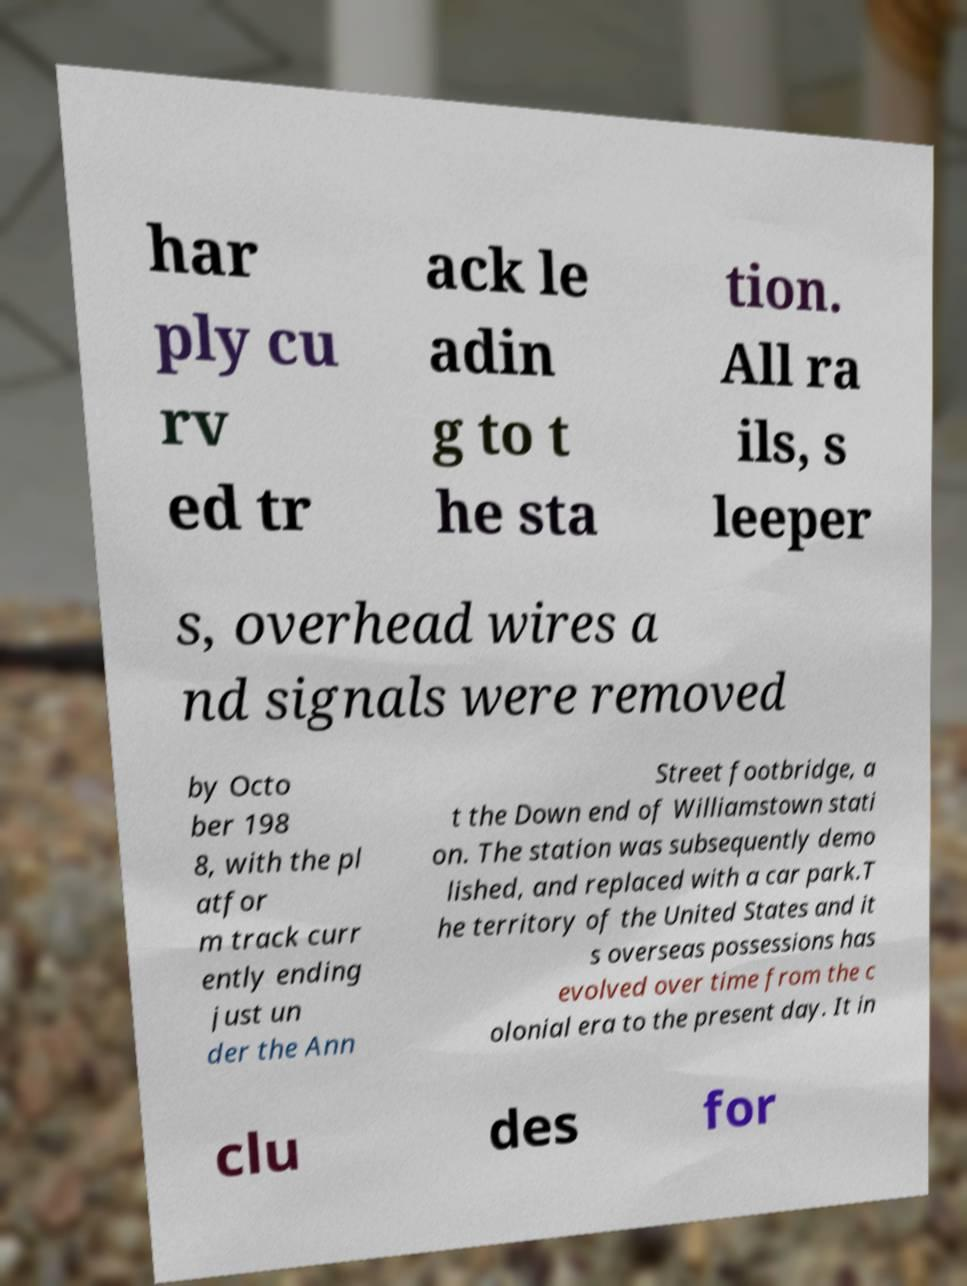Please identify and transcribe the text found in this image. har ply cu rv ed tr ack le adin g to t he sta tion. All ra ils, s leeper s, overhead wires a nd signals were removed by Octo ber 198 8, with the pl atfor m track curr ently ending just un der the Ann Street footbridge, a t the Down end of Williamstown stati on. The station was subsequently demo lished, and replaced with a car park.T he territory of the United States and it s overseas possessions has evolved over time from the c olonial era to the present day. It in clu des for 